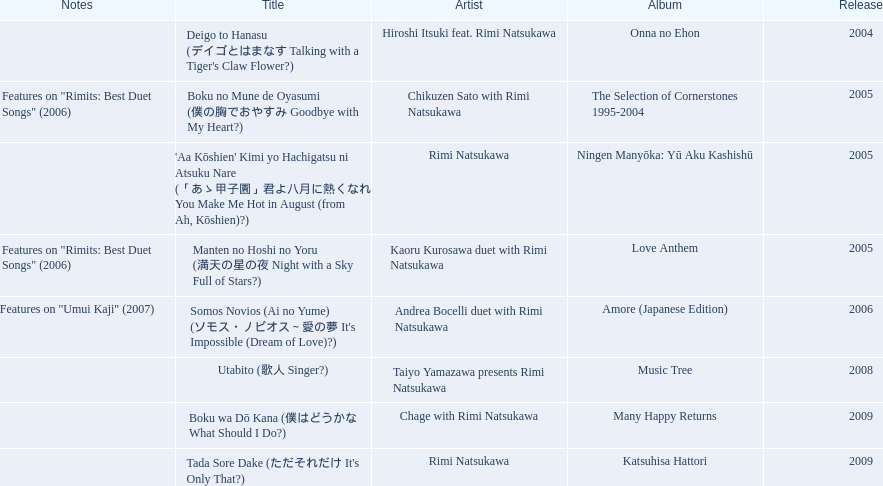What are the names of each album by rimi natsukawa? Onna no Ehon, The Selection of Cornerstones 1995-2004, Ningen Manyōka: Yū Aku Kashishū, Love Anthem, Amore (Japanese Edition), Music Tree, Many Happy Returns, Katsuhisa Hattori. And when were the albums released? 2004, 2005, 2005, 2005, 2006, 2008, 2009, 2009. Was onna no ehon or music tree released most recently? Music Tree. 